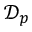Convert formula to latex. <formula><loc_0><loc_0><loc_500><loc_500>\mathcal { D } _ { p }</formula> 